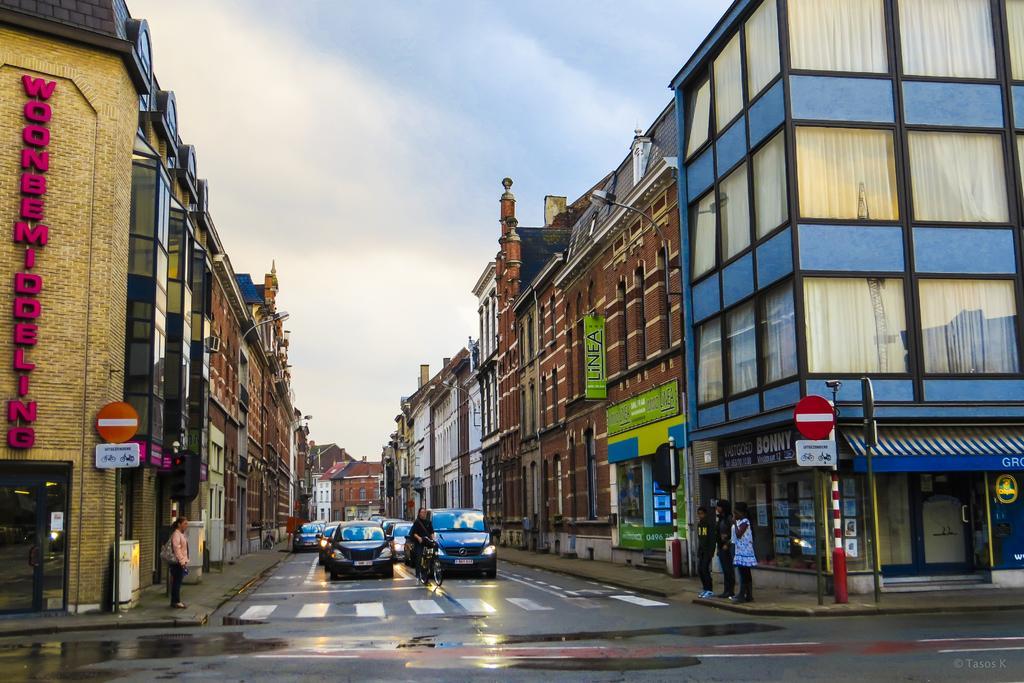Describe this image in one or two sentences. In this image there is the sky towards the top of the image, there are clouds in the sky, there are buildings towards the right of the image, there are buildings towards the left of the image, there is text on the building, there are doors, there are windows, there are poles, there are boards, there is text on the board, there are persons standing, there is the road towards the bottom of the image, there are vehicles on the road, there is text towards the bottom of the image. 